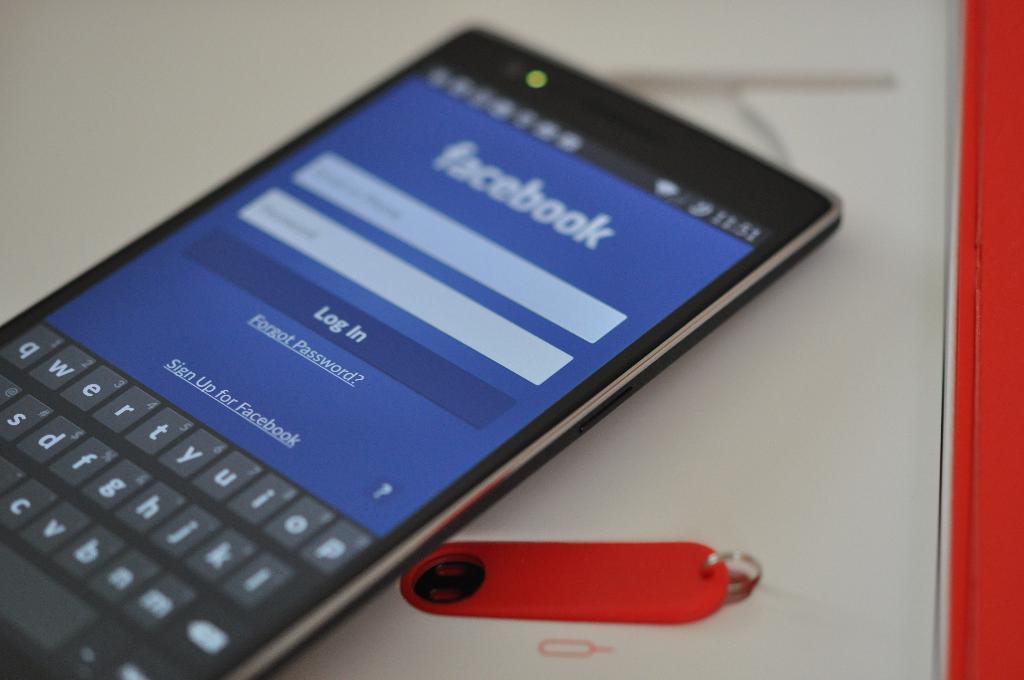Please provide a concise description of this image. In this picture there is a cell phone. On the screen there is text. At the bottom it looks like a book and there is a paper clip on it. 